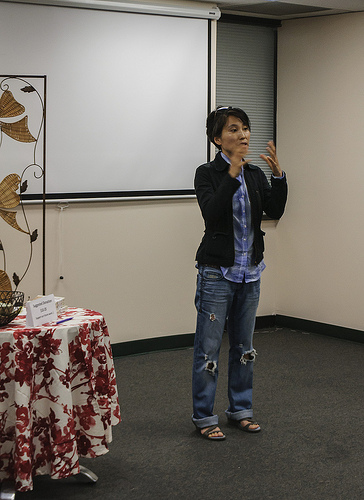<image>
Can you confirm if the woman is on the floor? Yes. Looking at the image, I can see the woman is positioned on top of the floor, with the floor providing support. 